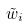Convert formula to latex. <formula><loc_0><loc_0><loc_500><loc_500>\tilde { w } _ { i }</formula> 